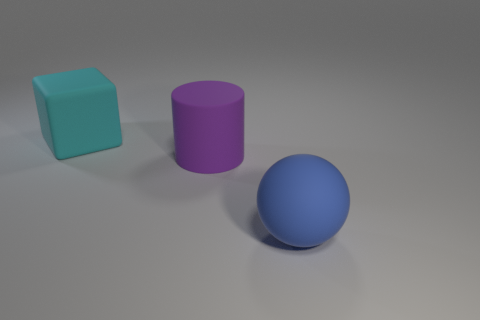Add 1 large cyan cubes. How many large cyan cubes exist? 2 Add 3 large rubber spheres. How many objects exist? 6 Subtract 0 red blocks. How many objects are left? 3 Subtract all balls. How many objects are left? 2 Subtract all gray cubes. Subtract all purple cylinders. How many cubes are left? 1 Subtract all big rubber spheres. Subtract all cubes. How many objects are left? 1 Add 1 cylinders. How many cylinders are left? 2 